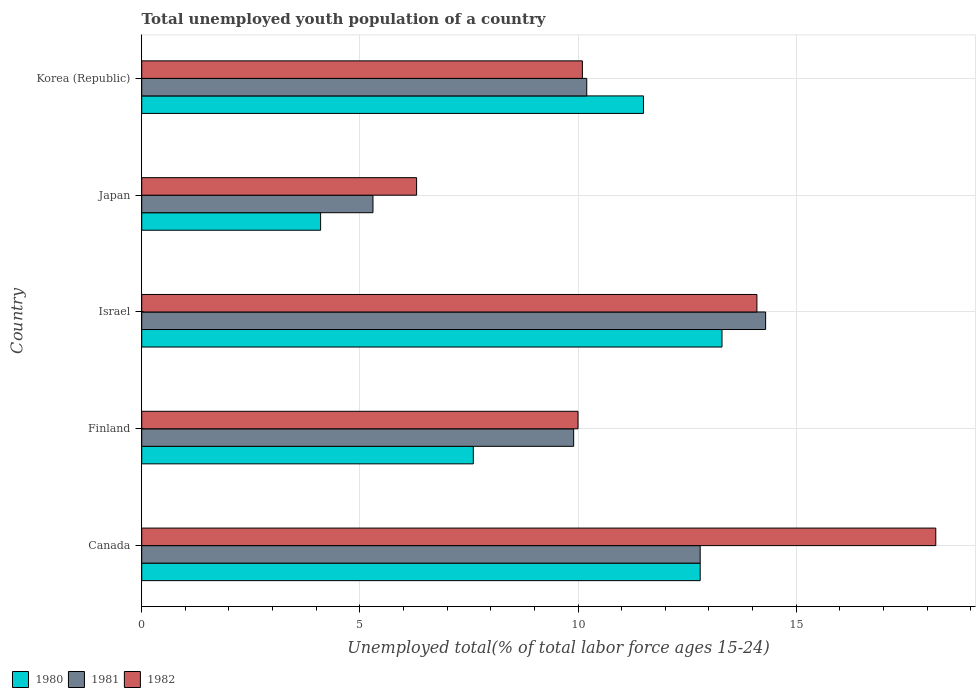Are the number of bars on each tick of the Y-axis equal?
Keep it short and to the point. Yes. How many bars are there on the 1st tick from the top?
Your answer should be very brief. 3. How many bars are there on the 3rd tick from the bottom?
Ensure brevity in your answer.  3. In how many cases, is the number of bars for a given country not equal to the number of legend labels?
Your answer should be very brief. 0. What is the percentage of total unemployed youth population of a country in 1980 in Japan?
Provide a short and direct response. 4.1. Across all countries, what is the maximum percentage of total unemployed youth population of a country in 1982?
Your answer should be compact. 18.2. Across all countries, what is the minimum percentage of total unemployed youth population of a country in 1980?
Your response must be concise. 4.1. In which country was the percentage of total unemployed youth population of a country in 1981 maximum?
Ensure brevity in your answer.  Israel. In which country was the percentage of total unemployed youth population of a country in 1980 minimum?
Provide a short and direct response. Japan. What is the total percentage of total unemployed youth population of a country in 1982 in the graph?
Your answer should be compact. 58.7. What is the difference between the percentage of total unemployed youth population of a country in 1982 in Finland and that in Israel?
Offer a very short reply. -4.1. What is the difference between the percentage of total unemployed youth population of a country in 1981 in Israel and the percentage of total unemployed youth population of a country in 1982 in Korea (Republic)?
Ensure brevity in your answer.  4.2. What is the average percentage of total unemployed youth population of a country in 1981 per country?
Give a very brief answer. 10.5. What is the ratio of the percentage of total unemployed youth population of a country in 1982 in Japan to that in Korea (Republic)?
Offer a very short reply. 0.62. What is the difference between the highest and the lowest percentage of total unemployed youth population of a country in 1980?
Your response must be concise. 9.2. In how many countries, is the percentage of total unemployed youth population of a country in 1980 greater than the average percentage of total unemployed youth population of a country in 1980 taken over all countries?
Provide a short and direct response. 3. Is the sum of the percentage of total unemployed youth population of a country in 1981 in Israel and Japan greater than the maximum percentage of total unemployed youth population of a country in 1980 across all countries?
Offer a terse response. Yes. What does the 1st bar from the top in Korea (Republic) represents?
Offer a terse response. 1982. What does the 1st bar from the bottom in Japan represents?
Your response must be concise. 1980. Is it the case that in every country, the sum of the percentage of total unemployed youth population of a country in 1981 and percentage of total unemployed youth population of a country in 1980 is greater than the percentage of total unemployed youth population of a country in 1982?
Your answer should be very brief. Yes. Are all the bars in the graph horizontal?
Provide a short and direct response. Yes. Where does the legend appear in the graph?
Your answer should be very brief. Bottom left. How many legend labels are there?
Keep it short and to the point. 3. What is the title of the graph?
Keep it short and to the point. Total unemployed youth population of a country. Does "1992" appear as one of the legend labels in the graph?
Your answer should be compact. No. What is the label or title of the X-axis?
Your answer should be very brief. Unemployed total(% of total labor force ages 15-24). What is the Unemployed total(% of total labor force ages 15-24) of 1980 in Canada?
Make the answer very short. 12.8. What is the Unemployed total(% of total labor force ages 15-24) in 1981 in Canada?
Your response must be concise. 12.8. What is the Unemployed total(% of total labor force ages 15-24) in 1982 in Canada?
Keep it short and to the point. 18.2. What is the Unemployed total(% of total labor force ages 15-24) in 1980 in Finland?
Ensure brevity in your answer.  7.6. What is the Unemployed total(% of total labor force ages 15-24) of 1981 in Finland?
Offer a terse response. 9.9. What is the Unemployed total(% of total labor force ages 15-24) in 1980 in Israel?
Provide a short and direct response. 13.3. What is the Unemployed total(% of total labor force ages 15-24) in 1981 in Israel?
Offer a terse response. 14.3. What is the Unemployed total(% of total labor force ages 15-24) of 1982 in Israel?
Your response must be concise. 14.1. What is the Unemployed total(% of total labor force ages 15-24) in 1980 in Japan?
Provide a succinct answer. 4.1. What is the Unemployed total(% of total labor force ages 15-24) in 1981 in Japan?
Make the answer very short. 5.3. What is the Unemployed total(% of total labor force ages 15-24) of 1982 in Japan?
Give a very brief answer. 6.3. What is the Unemployed total(% of total labor force ages 15-24) in 1981 in Korea (Republic)?
Your response must be concise. 10.2. What is the Unemployed total(% of total labor force ages 15-24) of 1982 in Korea (Republic)?
Your answer should be compact. 10.1. Across all countries, what is the maximum Unemployed total(% of total labor force ages 15-24) of 1980?
Your answer should be compact. 13.3. Across all countries, what is the maximum Unemployed total(% of total labor force ages 15-24) of 1981?
Offer a very short reply. 14.3. Across all countries, what is the maximum Unemployed total(% of total labor force ages 15-24) in 1982?
Your answer should be very brief. 18.2. Across all countries, what is the minimum Unemployed total(% of total labor force ages 15-24) of 1980?
Offer a very short reply. 4.1. Across all countries, what is the minimum Unemployed total(% of total labor force ages 15-24) of 1981?
Give a very brief answer. 5.3. Across all countries, what is the minimum Unemployed total(% of total labor force ages 15-24) of 1982?
Your answer should be compact. 6.3. What is the total Unemployed total(% of total labor force ages 15-24) in 1980 in the graph?
Offer a terse response. 49.3. What is the total Unemployed total(% of total labor force ages 15-24) in 1981 in the graph?
Offer a very short reply. 52.5. What is the total Unemployed total(% of total labor force ages 15-24) in 1982 in the graph?
Offer a very short reply. 58.7. What is the difference between the Unemployed total(% of total labor force ages 15-24) in 1982 in Canada and that in Finland?
Ensure brevity in your answer.  8.2. What is the difference between the Unemployed total(% of total labor force ages 15-24) in 1982 in Canada and that in Israel?
Your answer should be compact. 4.1. What is the difference between the Unemployed total(% of total labor force ages 15-24) of 1980 in Canada and that in Japan?
Give a very brief answer. 8.7. What is the difference between the Unemployed total(% of total labor force ages 15-24) of 1981 in Canada and that in Japan?
Ensure brevity in your answer.  7.5. What is the difference between the Unemployed total(% of total labor force ages 15-24) of 1981 in Canada and that in Korea (Republic)?
Keep it short and to the point. 2.6. What is the difference between the Unemployed total(% of total labor force ages 15-24) of 1980 in Finland and that in Israel?
Give a very brief answer. -5.7. What is the difference between the Unemployed total(% of total labor force ages 15-24) of 1981 in Finland and that in Israel?
Your response must be concise. -4.4. What is the difference between the Unemployed total(% of total labor force ages 15-24) of 1982 in Finland and that in Israel?
Provide a succinct answer. -4.1. What is the difference between the Unemployed total(% of total labor force ages 15-24) of 1980 in Finland and that in Japan?
Keep it short and to the point. 3.5. What is the difference between the Unemployed total(% of total labor force ages 15-24) of 1981 in Finland and that in Korea (Republic)?
Keep it short and to the point. -0.3. What is the difference between the Unemployed total(% of total labor force ages 15-24) of 1980 in Israel and that in Korea (Republic)?
Your response must be concise. 1.8. What is the difference between the Unemployed total(% of total labor force ages 15-24) in 1982 in Japan and that in Korea (Republic)?
Keep it short and to the point. -3.8. What is the difference between the Unemployed total(% of total labor force ages 15-24) of 1980 in Canada and the Unemployed total(% of total labor force ages 15-24) of 1982 in Finland?
Make the answer very short. 2.8. What is the difference between the Unemployed total(% of total labor force ages 15-24) in 1980 in Canada and the Unemployed total(% of total labor force ages 15-24) in 1981 in Israel?
Ensure brevity in your answer.  -1.5. What is the difference between the Unemployed total(% of total labor force ages 15-24) in 1980 in Canada and the Unemployed total(% of total labor force ages 15-24) in 1982 in Israel?
Provide a succinct answer. -1.3. What is the difference between the Unemployed total(% of total labor force ages 15-24) of 1981 in Canada and the Unemployed total(% of total labor force ages 15-24) of 1982 in Israel?
Provide a short and direct response. -1.3. What is the difference between the Unemployed total(% of total labor force ages 15-24) in 1980 in Canada and the Unemployed total(% of total labor force ages 15-24) in 1982 in Japan?
Make the answer very short. 6.5. What is the difference between the Unemployed total(% of total labor force ages 15-24) in 1980 in Finland and the Unemployed total(% of total labor force ages 15-24) in 1981 in Israel?
Keep it short and to the point. -6.7. What is the difference between the Unemployed total(% of total labor force ages 15-24) in 1981 in Finland and the Unemployed total(% of total labor force ages 15-24) in 1982 in Israel?
Your answer should be compact. -4.2. What is the difference between the Unemployed total(% of total labor force ages 15-24) of 1980 in Finland and the Unemployed total(% of total labor force ages 15-24) of 1981 in Japan?
Provide a short and direct response. 2.3. What is the difference between the Unemployed total(% of total labor force ages 15-24) of 1981 in Finland and the Unemployed total(% of total labor force ages 15-24) of 1982 in Japan?
Provide a succinct answer. 3.6. What is the difference between the Unemployed total(% of total labor force ages 15-24) of 1980 in Finland and the Unemployed total(% of total labor force ages 15-24) of 1982 in Korea (Republic)?
Make the answer very short. -2.5. What is the difference between the Unemployed total(% of total labor force ages 15-24) of 1981 in Finland and the Unemployed total(% of total labor force ages 15-24) of 1982 in Korea (Republic)?
Offer a very short reply. -0.2. What is the difference between the Unemployed total(% of total labor force ages 15-24) of 1980 in Israel and the Unemployed total(% of total labor force ages 15-24) of 1981 in Japan?
Provide a short and direct response. 8. What is the difference between the Unemployed total(% of total labor force ages 15-24) of 1980 in Israel and the Unemployed total(% of total labor force ages 15-24) of 1982 in Japan?
Ensure brevity in your answer.  7. What is the difference between the Unemployed total(% of total labor force ages 15-24) in 1980 in Israel and the Unemployed total(% of total labor force ages 15-24) in 1981 in Korea (Republic)?
Provide a short and direct response. 3.1. What is the difference between the Unemployed total(% of total labor force ages 15-24) of 1980 in Israel and the Unemployed total(% of total labor force ages 15-24) of 1982 in Korea (Republic)?
Provide a short and direct response. 3.2. What is the difference between the Unemployed total(% of total labor force ages 15-24) of 1980 in Japan and the Unemployed total(% of total labor force ages 15-24) of 1981 in Korea (Republic)?
Provide a succinct answer. -6.1. What is the difference between the Unemployed total(% of total labor force ages 15-24) in 1981 in Japan and the Unemployed total(% of total labor force ages 15-24) in 1982 in Korea (Republic)?
Offer a very short reply. -4.8. What is the average Unemployed total(% of total labor force ages 15-24) of 1980 per country?
Provide a short and direct response. 9.86. What is the average Unemployed total(% of total labor force ages 15-24) of 1981 per country?
Provide a succinct answer. 10.5. What is the average Unemployed total(% of total labor force ages 15-24) in 1982 per country?
Make the answer very short. 11.74. What is the difference between the Unemployed total(% of total labor force ages 15-24) of 1980 and Unemployed total(% of total labor force ages 15-24) of 1982 in Canada?
Your answer should be compact. -5.4. What is the difference between the Unemployed total(% of total labor force ages 15-24) in 1981 and Unemployed total(% of total labor force ages 15-24) in 1982 in Canada?
Your answer should be very brief. -5.4. What is the difference between the Unemployed total(% of total labor force ages 15-24) of 1980 and Unemployed total(% of total labor force ages 15-24) of 1981 in Finland?
Your response must be concise. -2.3. What is the difference between the Unemployed total(% of total labor force ages 15-24) of 1980 and Unemployed total(% of total labor force ages 15-24) of 1982 in Israel?
Offer a very short reply. -0.8. What is the difference between the Unemployed total(% of total labor force ages 15-24) of 1980 and Unemployed total(% of total labor force ages 15-24) of 1981 in Japan?
Keep it short and to the point. -1.2. What is the difference between the Unemployed total(% of total labor force ages 15-24) of 1980 and Unemployed total(% of total labor force ages 15-24) of 1981 in Korea (Republic)?
Give a very brief answer. 1.3. What is the difference between the Unemployed total(% of total labor force ages 15-24) in 1980 and Unemployed total(% of total labor force ages 15-24) in 1982 in Korea (Republic)?
Make the answer very short. 1.4. What is the difference between the Unemployed total(% of total labor force ages 15-24) in 1981 and Unemployed total(% of total labor force ages 15-24) in 1982 in Korea (Republic)?
Your answer should be compact. 0.1. What is the ratio of the Unemployed total(% of total labor force ages 15-24) in 1980 in Canada to that in Finland?
Your answer should be compact. 1.68. What is the ratio of the Unemployed total(% of total labor force ages 15-24) of 1981 in Canada to that in Finland?
Give a very brief answer. 1.29. What is the ratio of the Unemployed total(% of total labor force ages 15-24) in 1982 in Canada to that in Finland?
Your response must be concise. 1.82. What is the ratio of the Unemployed total(% of total labor force ages 15-24) of 1980 in Canada to that in Israel?
Provide a short and direct response. 0.96. What is the ratio of the Unemployed total(% of total labor force ages 15-24) in 1981 in Canada to that in Israel?
Make the answer very short. 0.9. What is the ratio of the Unemployed total(% of total labor force ages 15-24) in 1982 in Canada to that in Israel?
Provide a short and direct response. 1.29. What is the ratio of the Unemployed total(% of total labor force ages 15-24) of 1980 in Canada to that in Japan?
Keep it short and to the point. 3.12. What is the ratio of the Unemployed total(% of total labor force ages 15-24) in 1981 in Canada to that in Japan?
Offer a terse response. 2.42. What is the ratio of the Unemployed total(% of total labor force ages 15-24) of 1982 in Canada to that in Japan?
Your answer should be very brief. 2.89. What is the ratio of the Unemployed total(% of total labor force ages 15-24) of 1980 in Canada to that in Korea (Republic)?
Your answer should be very brief. 1.11. What is the ratio of the Unemployed total(% of total labor force ages 15-24) in 1981 in Canada to that in Korea (Republic)?
Your answer should be compact. 1.25. What is the ratio of the Unemployed total(% of total labor force ages 15-24) of 1982 in Canada to that in Korea (Republic)?
Offer a terse response. 1.8. What is the ratio of the Unemployed total(% of total labor force ages 15-24) of 1980 in Finland to that in Israel?
Offer a terse response. 0.57. What is the ratio of the Unemployed total(% of total labor force ages 15-24) of 1981 in Finland to that in Israel?
Your answer should be very brief. 0.69. What is the ratio of the Unemployed total(% of total labor force ages 15-24) of 1982 in Finland to that in Israel?
Provide a succinct answer. 0.71. What is the ratio of the Unemployed total(% of total labor force ages 15-24) in 1980 in Finland to that in Japan?
Your response must be concise. 1.85. What is the ratio of the Unemployed total(% of total labor force ages 15-24) of 1981 in Finland to that in Japan?
Your answer should be very brief. 1.87. What is the ratio of the Unemployed total(% of total labor force ages 15-24) in 1982 in Finland to that in Japan?
Ensure brevity in your answer.  1.59. What is the ratio of the Unemployed total(% of total labor force ages 15-24) of 1980 in Finland to that in Korea (Republic)?
Make the answer very short. 0.66. What is the ratio of the Unemployed total(% of total labor force ages 15-24) in 1981 in Finland to that in Korea (Republic)?
Provide a short and direct response. 0.97. What is the ratio of the Unemployed total(% of total labor force ages 15-24) of 1980 in Israel to that in Japan?
Give a very brief answer. 3.24. What is the ratio of the Unemployed total(% of total labor force ages 15-24) of 1981 in Israel to that in Japan?
Offer a terse response. 2.7. What is the ratio of the Unemployed total(% of total labor force ages 15-24) of 1982 in Israel to that in Japan?
Make the answer very short. 2.24. What is the ratio of the Unemployed total(% of total labor force ages 15-24) in 1980 in Israel to that in Korea (Republic)?
Your answer should be compact. 1.16. What is the ratio of the Unemployed total(% of total labor force ages 15-24) in 1981 in Israel to that in Korea (Republic)?
Make the answer very short. 1.4. What is the ratio of the Unemployed total(% of total labor force ages 15-24) of 1982 in Israel to that in Korea (Republic)?
Give a very brief answer. 1.4. What is the ratio of the Unemployed total(% of total labor force ages 15-24) in 1980 in Japan to that in Korea (Republic)?
Your response must be concise. 0.36. What is the ratio of the Unemployed total(% of total labor force ages 15-24) of 1981 in Japan to that in Korea (Republic)?
Offer a very short reply. 0.52. What is the ratio of the Unemployed total(% of total labor force ages 15-24) of 1982 in Japan to that in Korea (Republic)?
Make the answer very short. 0.62. What is the difference between the highest and the lowest Unemployed total(% of total labor force ages 15-24) of 1982?
Your answer should be very brief. 11.9. 